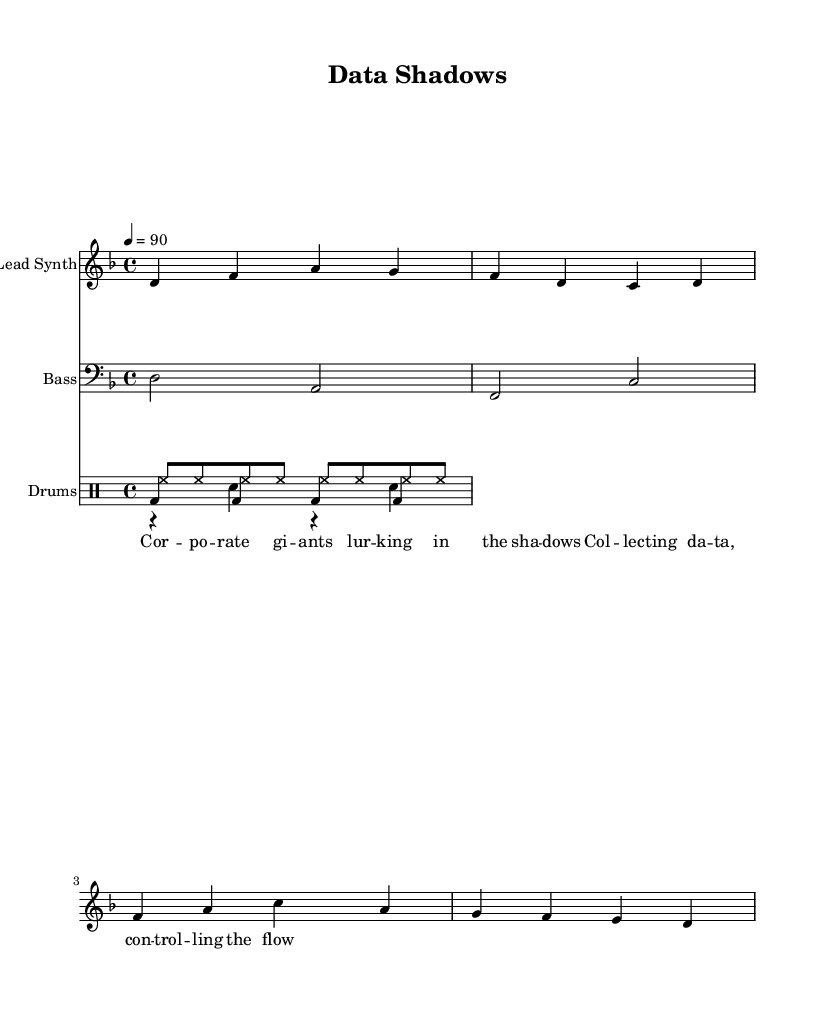What is the key signature of this music? The key signature is indicated at the beginning of the staff. It shows two flats, which means the piece is in D minor.
Answer: D minor What is the time signature of this music? The time signature is shown at the beginning of the staff after the key signature. It indicates that there are four beats per measure.
Answer: 4/4 What is the tempo marking for this composition? The tempo is indicated in beats per minute, which shows that the music should be played at a speed of 90 beats per minute.
Answer: 90 How many measures are in the lead synth part? Count the number of vertical lines (bar lines) separating the music into measures in the lead synth part. There are four measures in total.
Answer: 4 What type of rhythm does the drum pattern in the first voice consist of? The first drum voice features a kick drum pattern, indicated by the notation, which shows a steady beat with constant hits on the bass drum.
Answer: Kick drum What do the lyrics critique in this composition? The lyrics explicitly talk about corporate giants and their control over personal data, highlighting concerns about privacy and the influence of corporate power.
Answer: Corporate control What is the main theme expressed in the lyrics? The lyrics suggest a narrative of surveillance and data collection by corporate entities, which is a concern addressed in underground rap culture regarding individual privacy and autonomy.
Answer: Data collection 